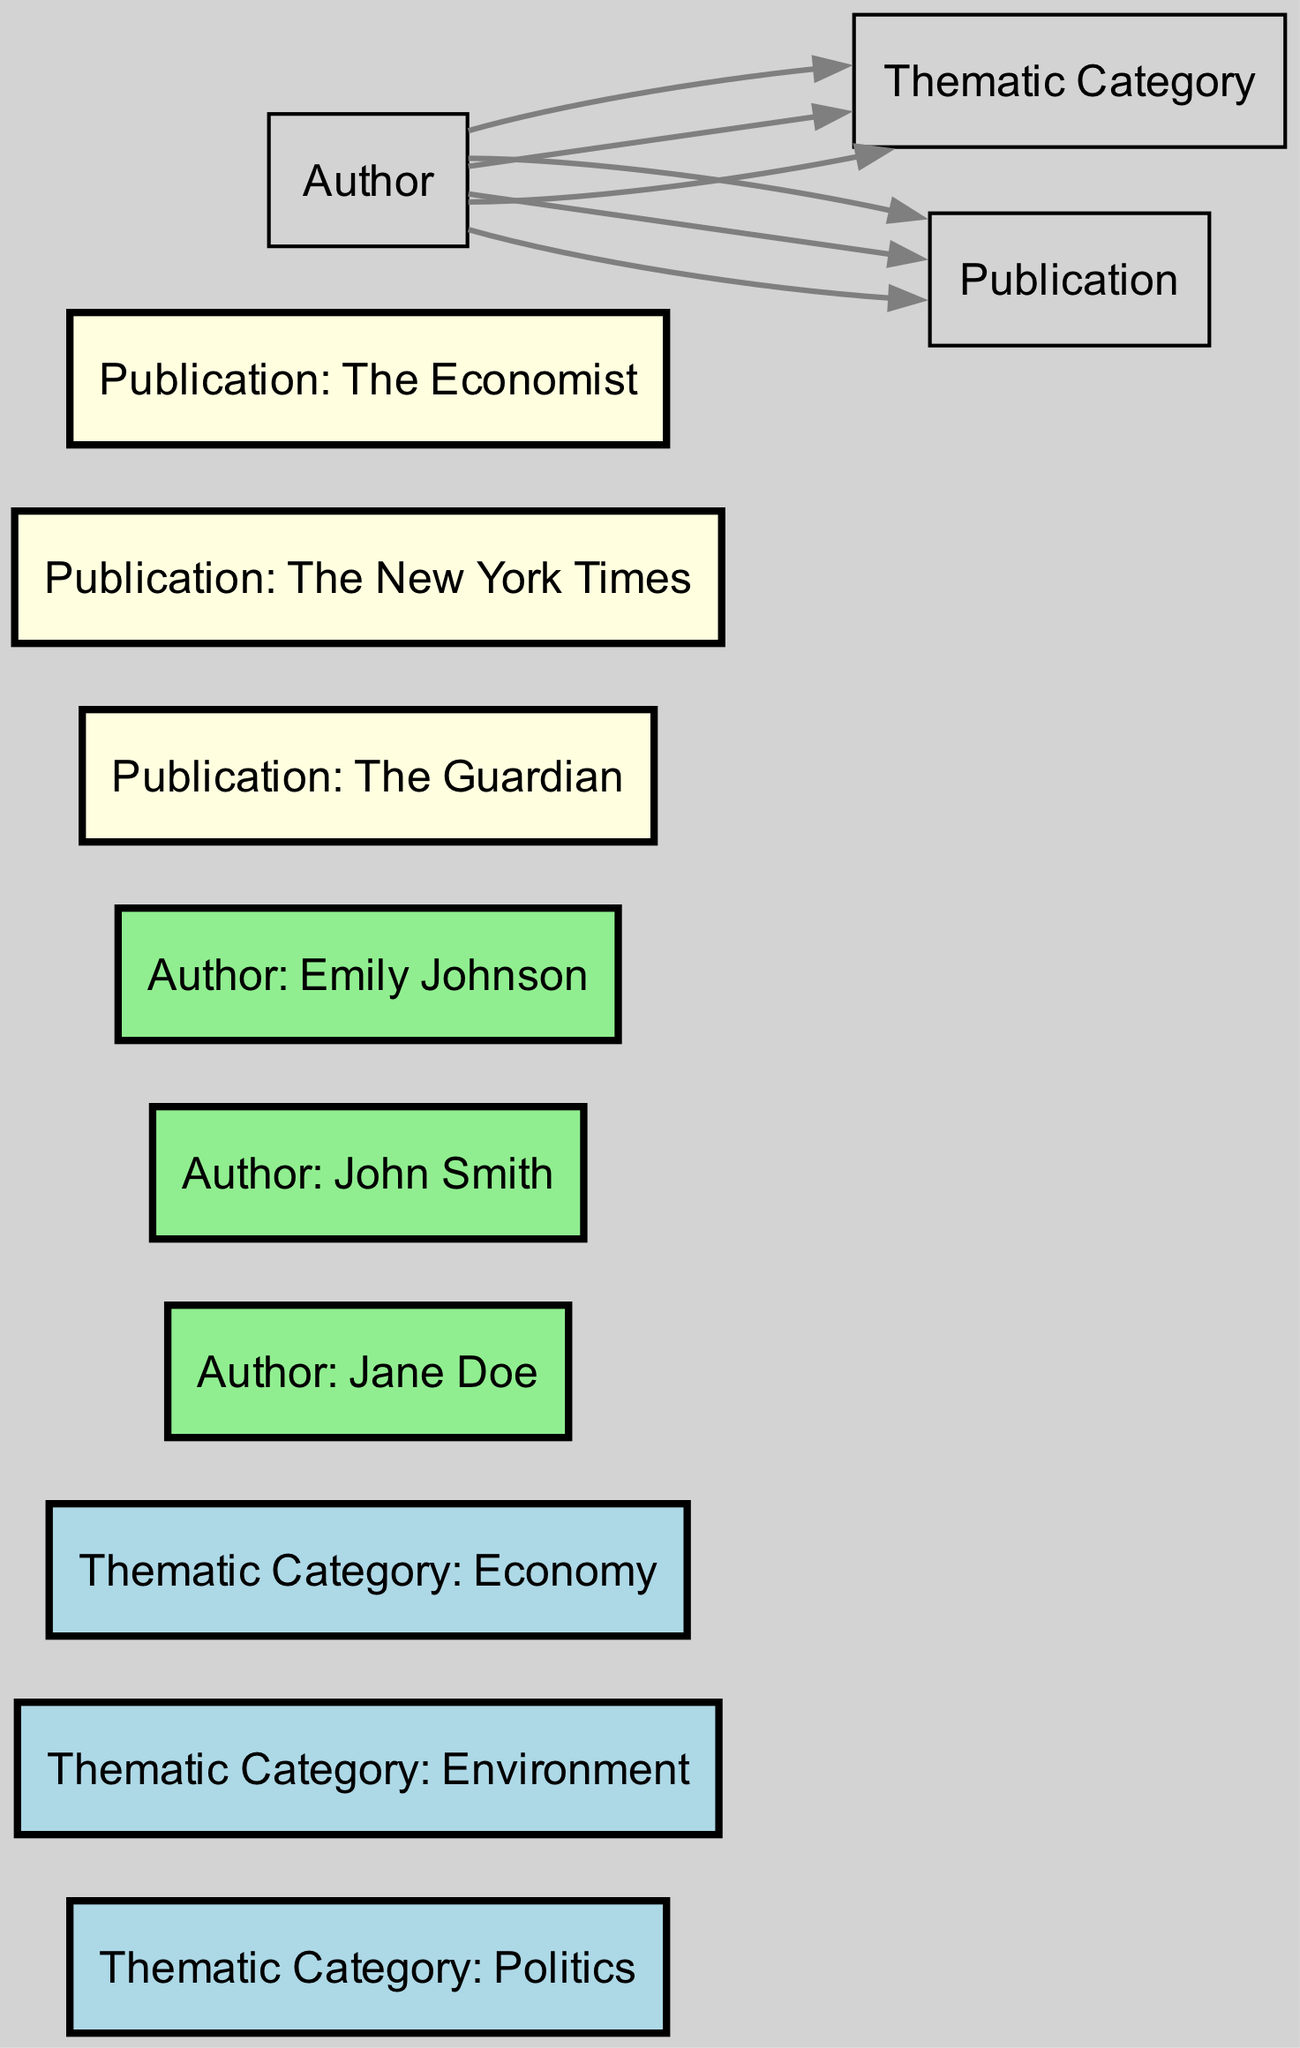What authors are associated with the thematic category Politics? By examining the edges connected to the thematic category "Politics," we see that "Author: Jane Doe" has a direct edge pointing to "Thematic Category: Politics," indicating that she is the only author associated with this category.
Answer: Jane Doe How many thematic categories are present in the diagram? The diagram contains three thematic categories: Politics, Environment, and Economy. By counting the nodes labeled as "Thematic Category," we can confirm that there are a total of three.
Answer: 3 Which publication is associated with the author John Smith? Looking at the directed edges from "Author: John Smith," we find that there is one edge leading to "Publication: The New York Times." This shows that John Smith's work is associated with this specific publication.
Answer: The New York Times Who is the author for the thematic category Environment? The edge from "Author: John Smith" to "Thematic Category: Environment" indicates that he is the author discussing topics related to this category, making him the associated author.
Answer: John Smith How many authors are associated with each thematic category? By examining the edges, we observe that "Thematic Category: Politics" is connected to 1 author (Jane Doe), "Thematic Category: Environment" is also connected to 1 author (John Smith), and "Thematic Category: Economy" is similarly connected to 1 author (Emily Johnson), leading to a total of 1 author per category.
Answer: 1 Which thematic category has the author Emily Johnson associated with it? The directed edge from "Author: Emily Johnson" to "Thematic Category: Economy" clearly specifies that she is connected to this category, making it the thematic focus of her work.
Answer: Economy What is the total number of edges in the diagram? By counting the connections, we find there are six edges in total; these edges connect the authors to the thematic categories and their respective publications.
Answer: 6 What publication is associated with the author Emily Johnson? The directed edge from "Author: Emily Johnson" to "Publication: The Economist" indicates that her work appears in this specific publication.
Answer: The Economist Which thematic category is not linked to Jane Doe? Looking at the edges connected to Jane Doe, we see she is associated with "Thematic Category: Politics" only, thus she has no links to "Environment" or "Economy." By process of elimination, those are the categories not connected to her.
Answer: Environment, Economy 